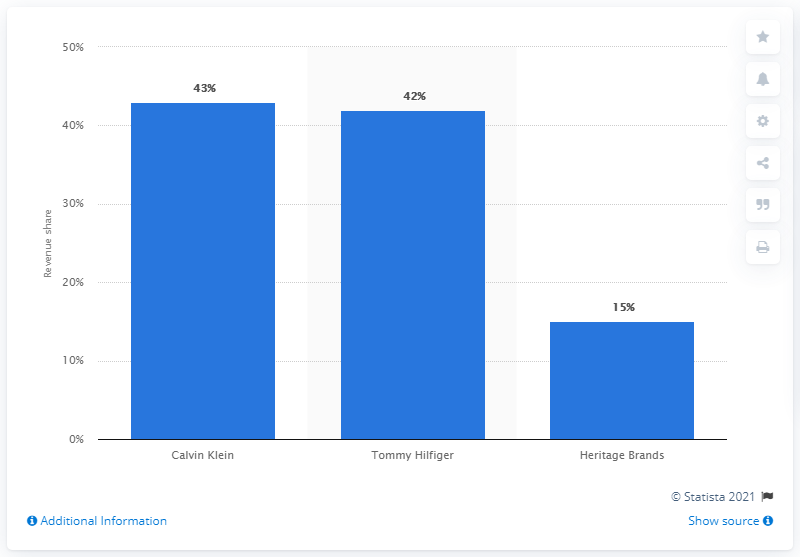List a handful of essential elements in this visual. In 2019, PVH Corporation generated 43% of its total revenue from the brand Calvin Klein. 